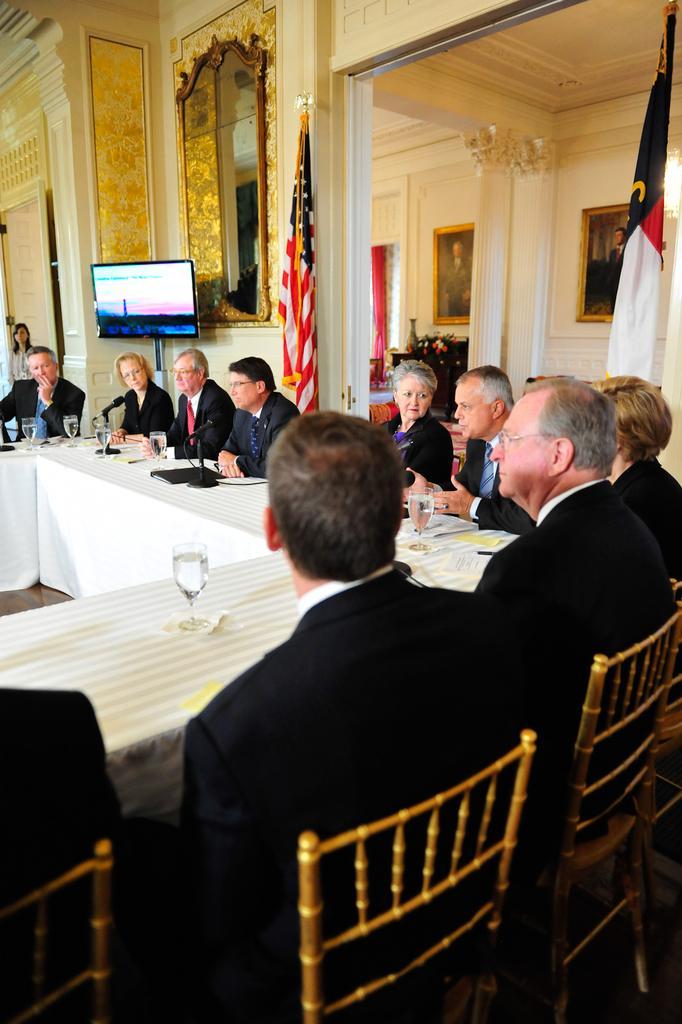How would you summarize this image in a sentence or two? In this picture we can see some persons are sitting on the chairs. This is table. On the table there are glasses. On the background there is a wall and these are the frames. Here we can see a screen and these are the flags. 